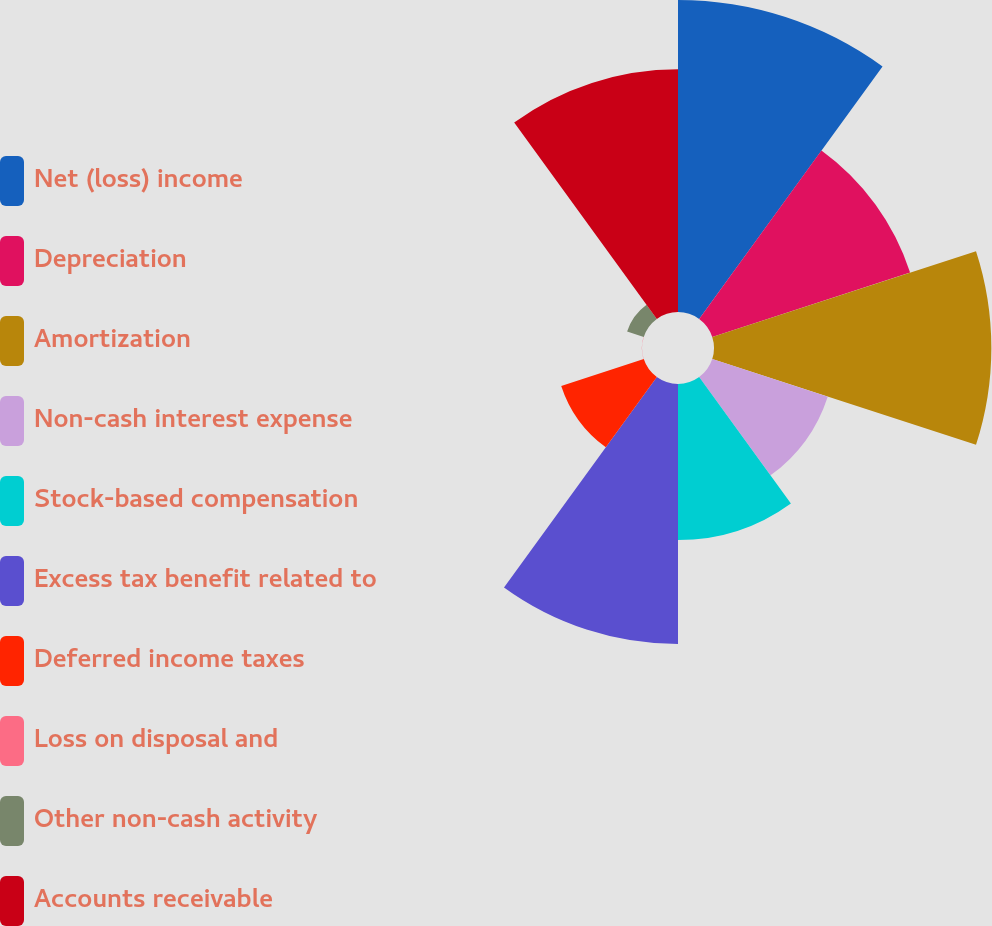<chart> <loc_0><loc_0><loc_500><loc_500><pie_chart><fcel>Net (loss) income<fcel>Depreciation<fcel>Amortization<fcel>Non-cash interest expense<fcel>Stock-based compensation<fcel>Excess tax benefit related to<fcel>Deferred income taxes<fcel>Loss on disposal and<fcel>Other non-cash activity<fcel>Accounts receivable<nl><fcel>18.55%<fcel>12.37%<fcel>16.49%<fcel>7.22%<fcel>9.28%<fcel>15.46%<fcel>5.16%<fcel>0.01%<fcel>1.04%<fcel>14.43%<nl></chart> 